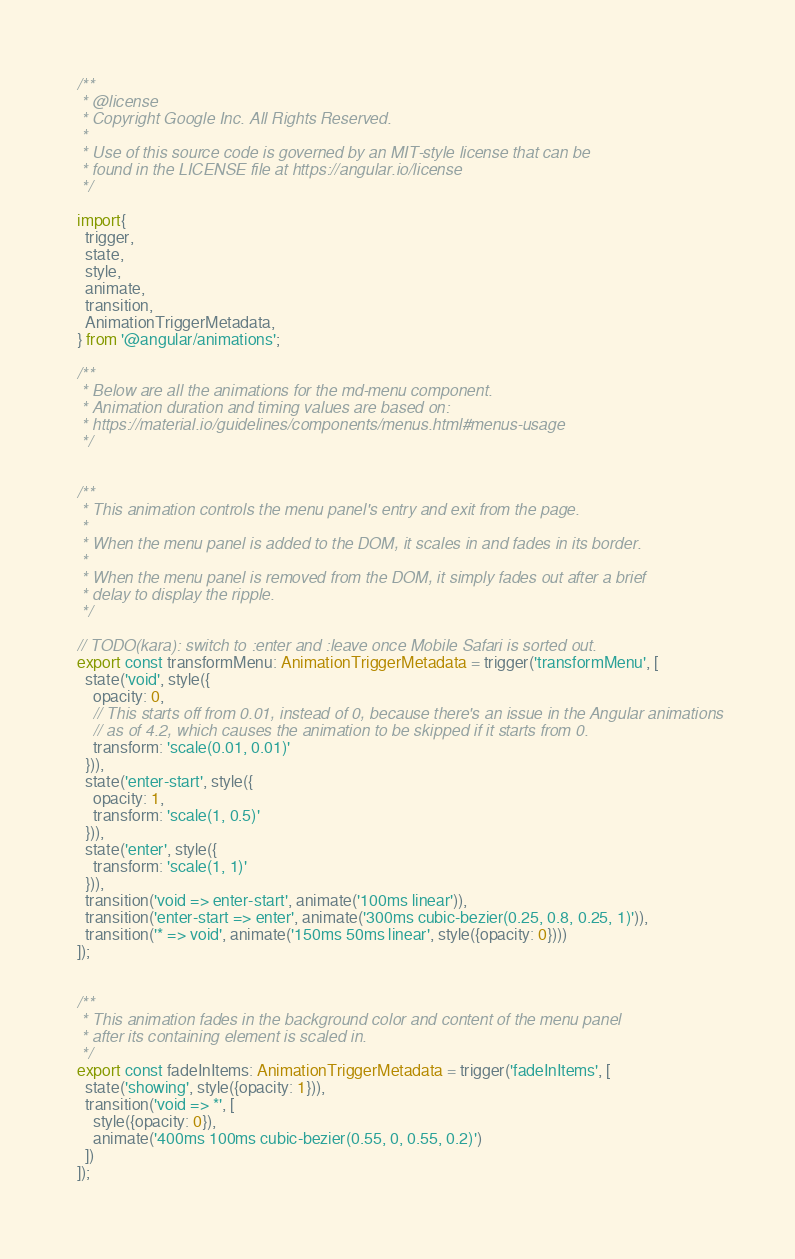<code> <loc_0><loc_0><loc_500><loc_500><_TypeScript_>/**
 * @license
 * Copyright Google Inc. All Rights Reserved.
 *
 * Use of this source code is governed by an MIT-style license that can be
 * found in the LICENSE file at https://angular.io/license
 */

import{
  trigger,
  state,
  style,
  animate,
  transition,
  AnimationTriggerMetadata,
} from '@angular/animations';

/**
 * Below are all the animations for the md-menu component.
 * Animation duration and timing values are based on:
 * https://material.io/guidelines/components/menus.html#menus-usage
 */


/**
 * This animation controls the menu panel's entry and exit from the page.
 *
 * When the menu panel is added to the DOM, it scales in and fades in its border.
 *
 * When the menu panel is removed from the DOM, it simply fades out after a brief
 * delay to display the ripple.
 */

// TODO(kara): switch to :enter and :leave once Mobile Safari is sorted out.
export const transformMenu: AnimationTriggerMetadata = trigger('transformMenu', [
  state('void', style({
    opacity: 0,
    // This starts off from 0.01, instead of 0, because there's an issue in the Angular animations
    // as of 4.2, which causes the animation to be skipped if it starts from 0.
    transform: 'scale(0.01, 0.01)'
  })),
  state('enter-start', style({
    opacity: 1,
    transform: 'scale(1, 0.5)'
  })),
  state('enter', style({
    transform: 'scale(1, 1)'
  })),
  transition('void => enter-start', animate('100ms linear')),
  transition('enter-start => enter', animate('300ms cubic-bezier(0.25, 0.8, 0.25, 1)')),
  transition('* => void', animate('150ms 50ms linear', style({opacity: 0})))
]);


/**
 * This animation fades in the background color and content of the menu panel
 * after its containing element is scaled in.
 */
export const fadeInItems: AnimationTriggerMetadata = trigger('fadeInItems', [
  state('showing', style({opacity: 1})),
  transition('void => *', [
    style({opacity: 0}),
    animate('400ms 100ms cubic-bezier(0.55, 0, 0.55, 0.2)')
  ])
]);
</code> 